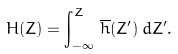Convert formula to latex. <formula><loc_0><loc_0><loc_500><loc_500>H ( Z ) = \int _ { - \infty } ^ { Z } \, \overline { h } ( Z ^ { \prime } ) \, d Z ^ { \prime } .</formula> 